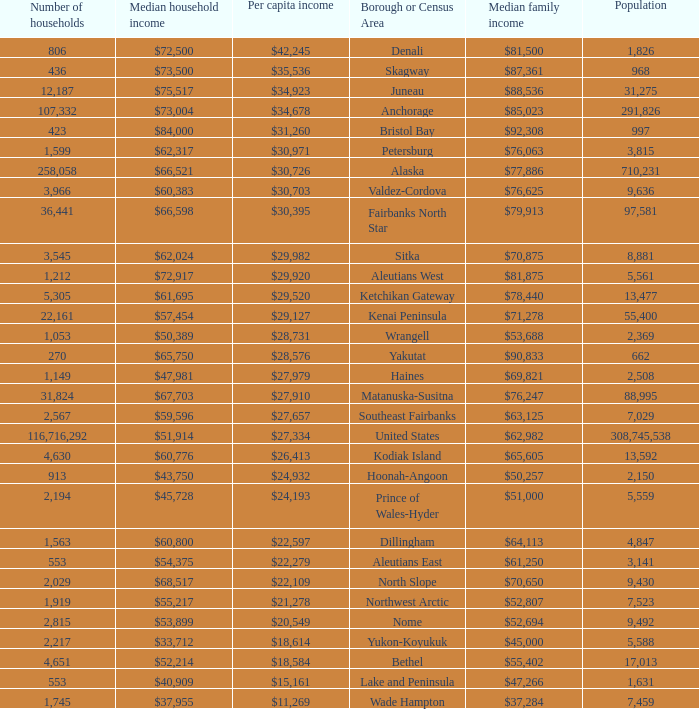What is the population of the area with a median family income of $71,278? 1.0. 